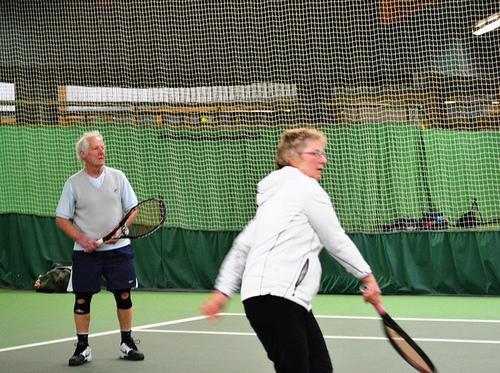How many people are pictured?
Give a very brief answer. 2. 